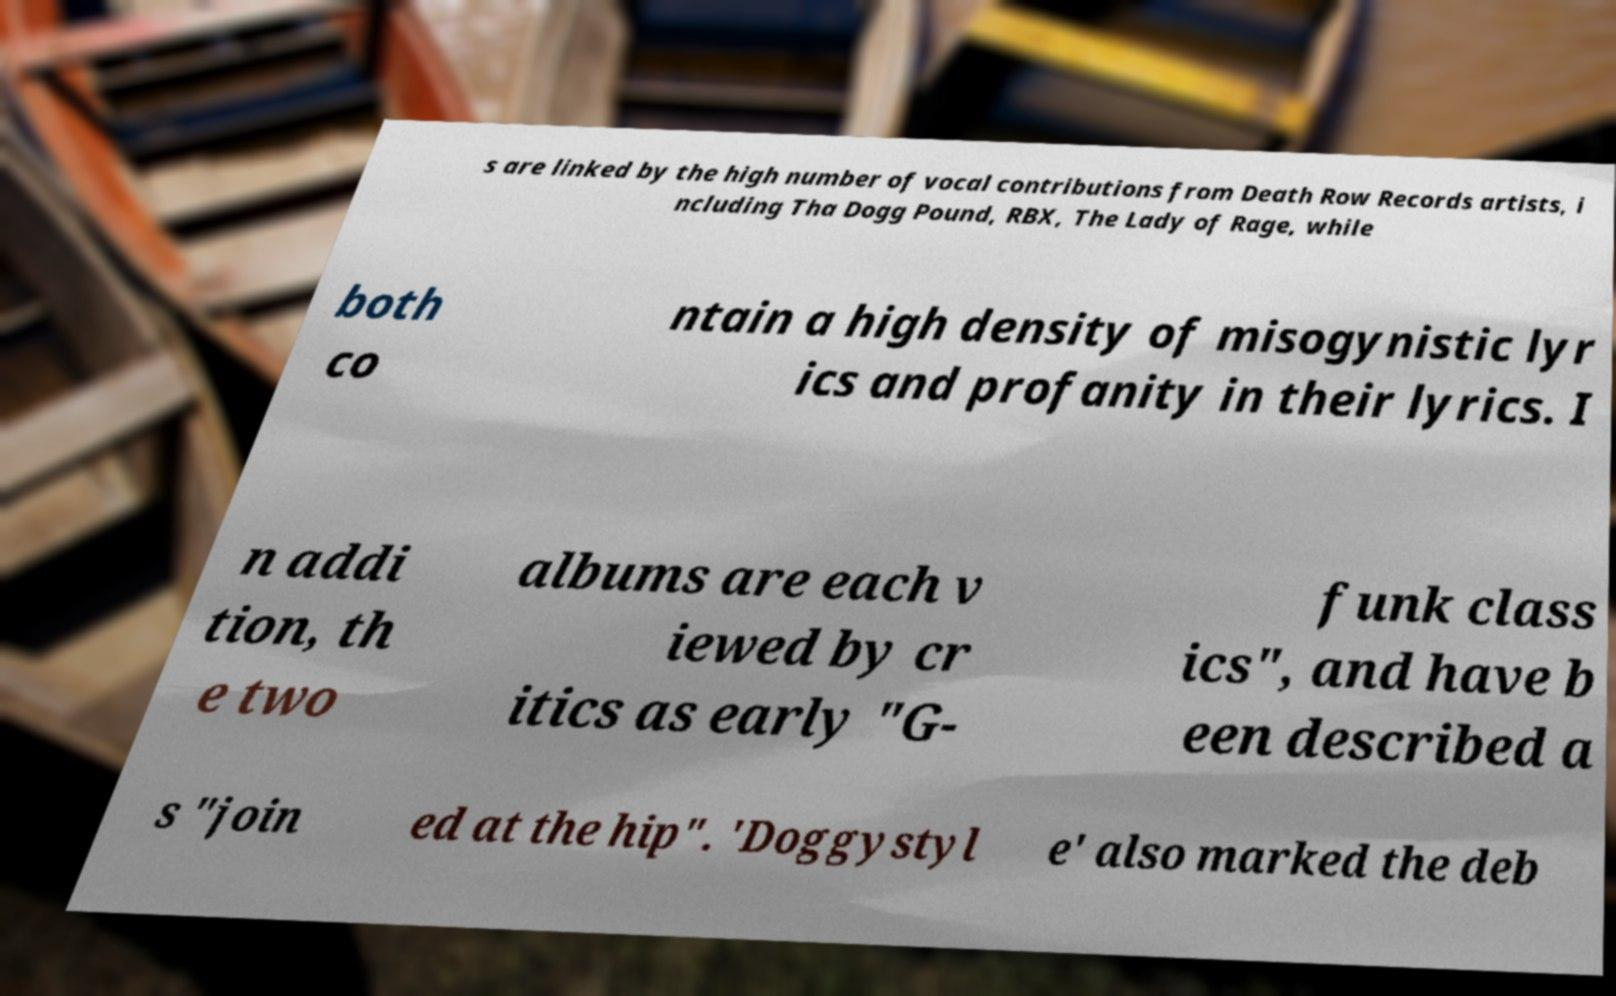Could you assist in decoding the text presented in this image and type it out clearly? s are linked by the high number of vocal contributions from Death Row Records artists, i ncluding Tha Dogg Pound, RBX, The Lady of Rage, while both co ntain a high density of misogynistic lyr ics and profanity in their lyrics. I n addi tion, th e two albums are each v iewed by cr itics as early "G- funk class ics", and have b een described a s "join ed at the hip". 'Doggystyl e' also marked the deb 